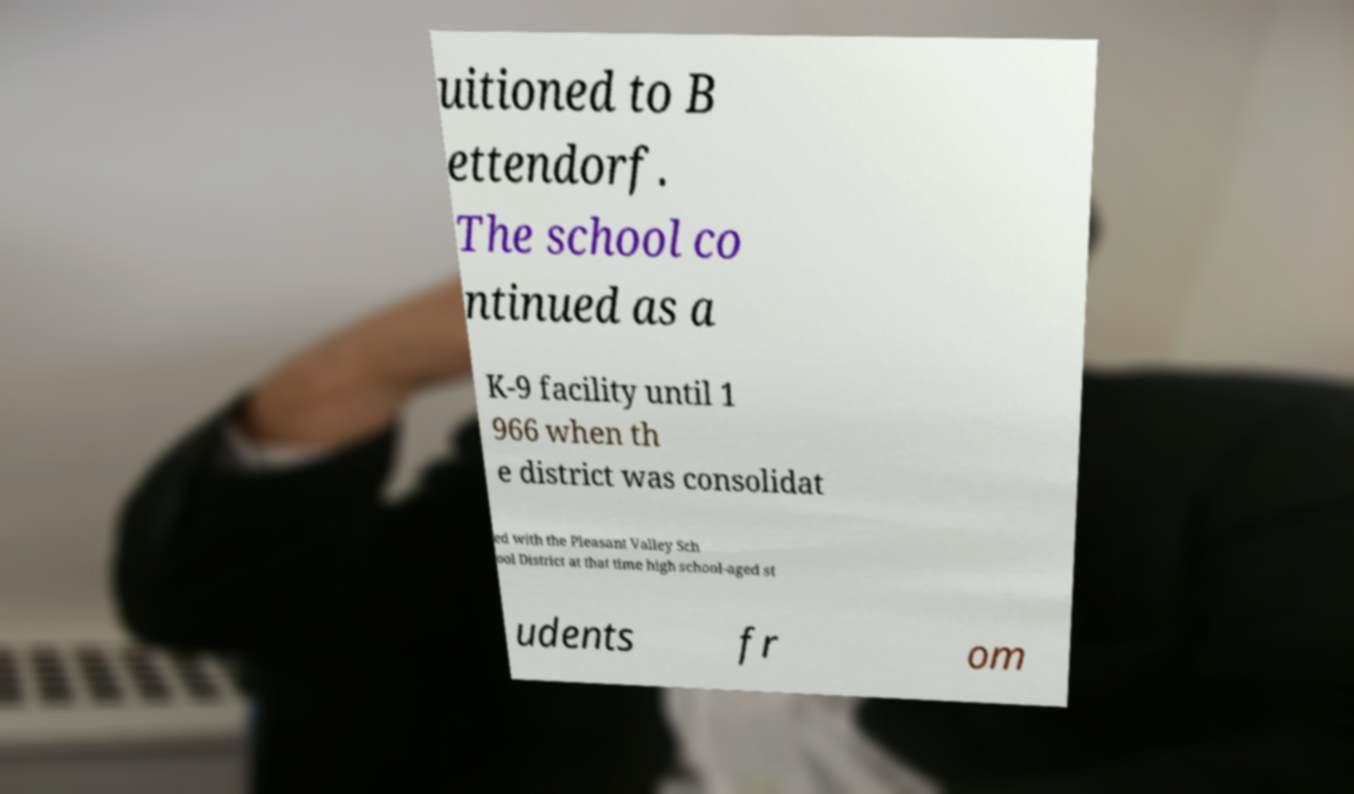Could you extract and type out the text from this image? uitioned to B ettendorf. The school co ntinued as a K-9 facility until 1 966 when th e district was consolidat ed with the Pleasant Valley Sch ool District at that time high school-aged st udents fr om 